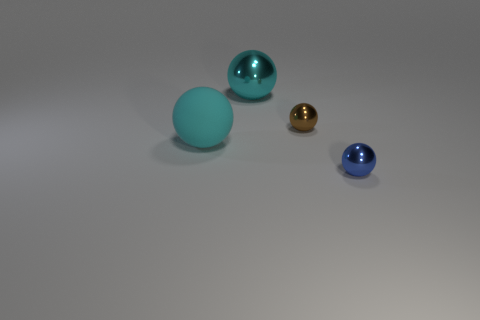What number of other objects are there of the same shape as the cyan metal object?
Keep it short and to the point. 3. Are there any large cyan shiny spheres on the right side of the matte object?
Keep it short and to the point. Yes. How many things are either purple cylinders or cyan things?
Keep it short and to the point. 2. How many things are both left of the brown ball and behind the cyan rubber thing?
Offer a terse response. 1. Do the sphere on the left side of the big metallic object and the blue ball to the right of the tiny brown metal sphere have the same size?
Offer a very short reply. No. What size is the cyan matte object behind the small blue ball?
Offer a terse response. Large. How many things are either spheres right of the cyan matte thing or balls on the right side of the cyan metallic ball?
Offer a terse response. 3. Is there anything else of the same color as the rubber thing?
Offer a very short reply. Yes. Are there an equal number of small blue spheres that are behind the blue metal object and large cyan metallic objects that are behind the cyan metallic object?
Ensure brevity in your answer.  Yes. Is the number of metal objects in front of the cyan shiny thing greater than the number of small red metallic spheres?
Give a very brief answer. Yes. 